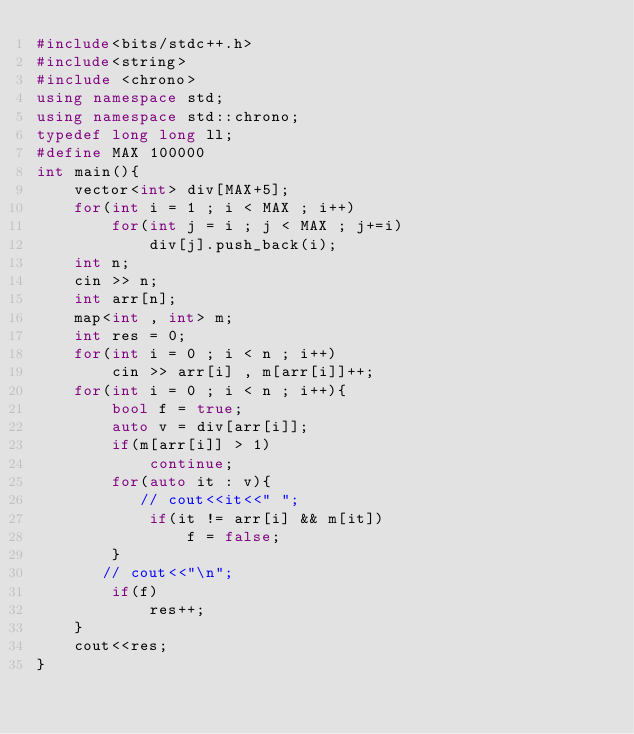Convert code to text. <code><loc_0><loc_0><loc_500><loc_500><_C++_>#include<bits/stdc++.h>
#include<string>
#include <chrono>
using namespace std;
using namespace std::chrono;
typedef long long ll;
#define MAX 100000
int main(){
    vector<int> div[MAX+5];
    for(int i = 1 ; i < MAX ; i++)
        for(int j = i ; j < MAX ; j+=i)
            div[j].push_back(i);
    int n;
    cin >> n;
    int arr[n];
    map<int , int> m;
    int res = 0;
    for(int i = 0 ; i < n ; i++)
        cin >> arr[i] , m[arr[i]]++;
    for(int i = 0 ; i < n ; i++){
        bool f = true;
        auto v = div[arr[i]];
        if(m[arr[i]] > 1)
            continue;
        for(auto it : v){
           // cout<<it<<" ";
            if(it != arr[i] && m[it])
                f = false;
        }
       // cout<<"\n";
        if(f)
            res++;
    }
    cout<<res;
}
</code> 